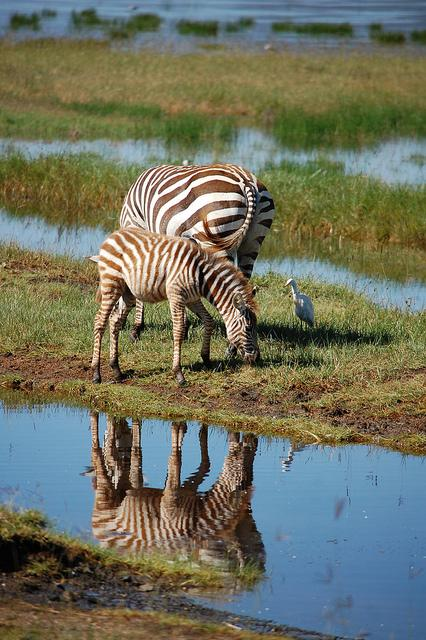Which animal is in danger from the other here? Please explain your reasoning. neither. The two breeds of animals are docile, friendly animals. 